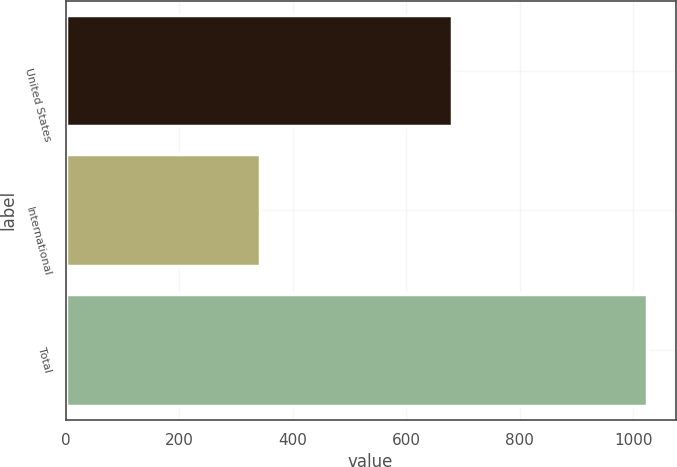<chart> <loc_0><loc_0><loc_500><loc_500><bar_chart><fcel>United States<fcel>International<fcel>Total<nl><fcel>680.8<fcel>342.5<fcel>1023.3<nl></chart> 